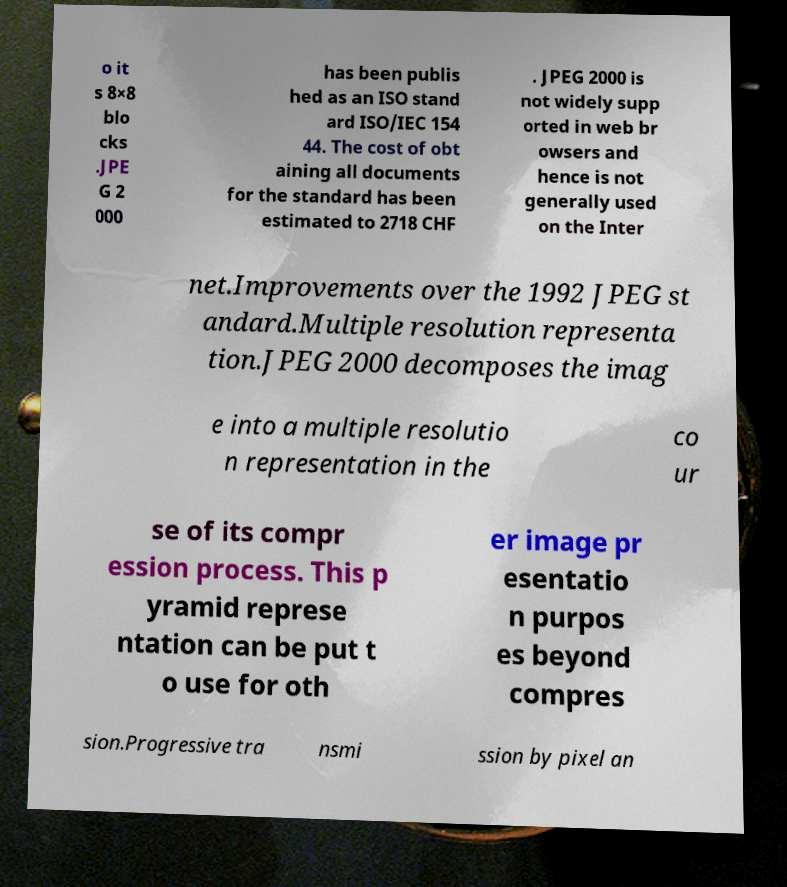I need the written content from this picture converted into text. Can you do that? o it s 8×8 blo cks .JPE G 2 000 has been publis hed as an ISO stand ard ISO/IEC 154 44. The cost of obt aining all documents for the standard has been estimated to 2718 CHF . JPEG 2000 is not widely supp orted in web br owsers and hence is not generally used on the Inter net.Improvements over the 1992 JPEG st andard.Multiple resolution representa tion.JPEG 2000 decomposes the imag e into a multiple resolutio n representation in the co ur se of its compr ession process. This p yramid represe ntation can be put t o use for oth er image pr esentatio n purpos es beyond compres sion.Progressive tra nsmi ssion by pixel an 